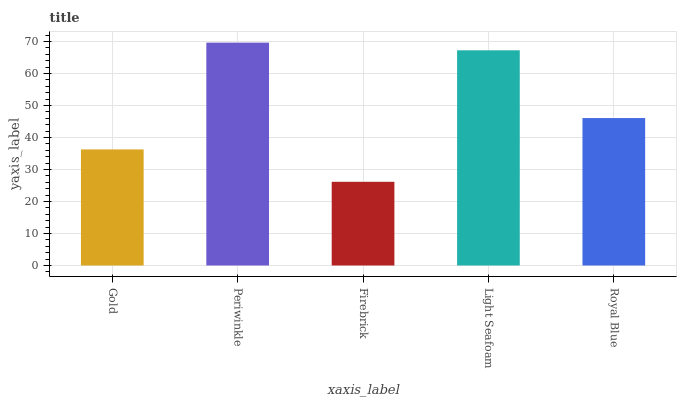Is Firebrick the minimum?
Answer yes or no. Yes. Is Periwinkle the maximum?
Answer yes or no. Yes. Is Periwinkle the minimum?
Answer yes or no. No. Is Firebrick the maximum?
Answer yes or no. No. Is Periwinkle greater than Firebrick?
Answer yes or no. Yes. Is Firebrick less than Periwinkle?
Answer yes or no. Yes. Is Firebrick greater than Periwinkle?
Answer yes or no. No. Is Periwinkle less than Firebrick?
Answer yes or no. No. Is Royal Blue the high median?
Answer yes or no. Yes. Is Royal Blue the low median?
Answer yes or no. Yes. Is Light Seafoam the high median?
Answer yes or no. No. Is Firebrick the low median?
Answer yes or no. No. 